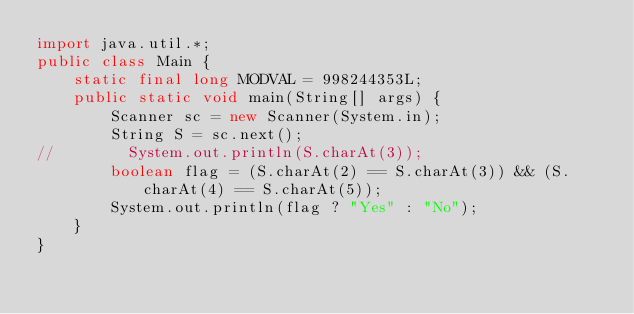Convert code to text. <code><loc_0><loc_0><loc_500><loc_500><_Java_>import java.util.*;
public class Main {
    static final long MODVAL = 998244353L;
    public static void main(String[] args) {
        Scanner sc = new Scanner(System.in);
        String S = sc.next();
//        System.out.println(S.charAt(3));
        boolean flag = (S.charAt(2) == S.charAt(3)) && (S.charAt(4) == S.charAt(5));
        System.out.println(flag ? "Yes" : "No");
    }
}
</code> 